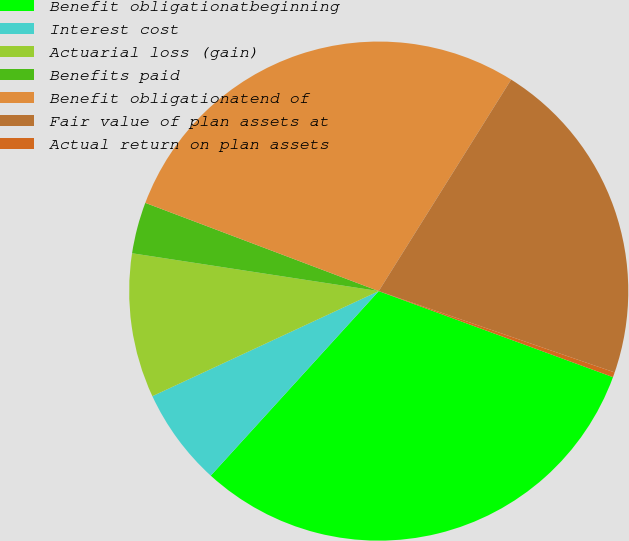Convert chart to OTSL. <chart><loc_0><loc_0><loc_500><loc_500><pie_chart><fcel>Benefit obligationatbeginning<fcel>Interest cost<fcel>Actuarial loss (gain)<fcel>Benefits paid<fcel>Benefit obligationatend of<fcel>Fair value of plan assets at<fcel>Actual return on plan assets<nl><fcel>31.15%<fcel>6.33%<fcel>9.34%<fcel>3.33%<fcel>28.15%<fcel>21.38%<fcel>0.32%<nl></chart> 